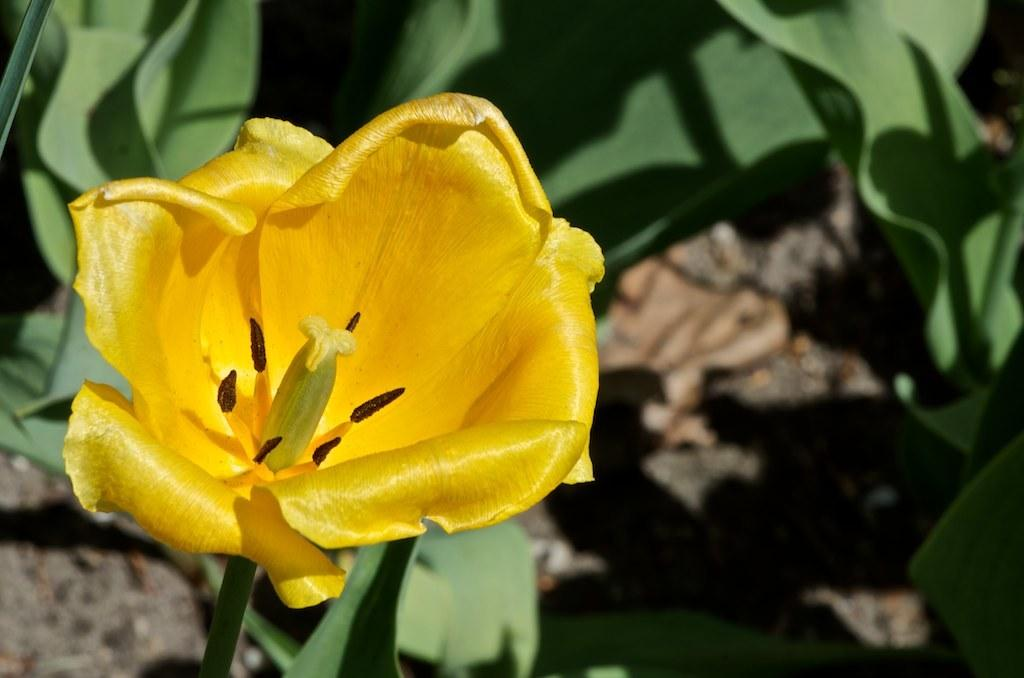What is the main subject of the image? There is a flower in the image. What can be seen behind the flower? There are leaves behind the flower in the image. What type of protest is happening in the image? There is no protest present in the image; it features a flower and leaves. Can you tell me where the church is located in the image? There is no church present in the image; it features a flower and leaves. 